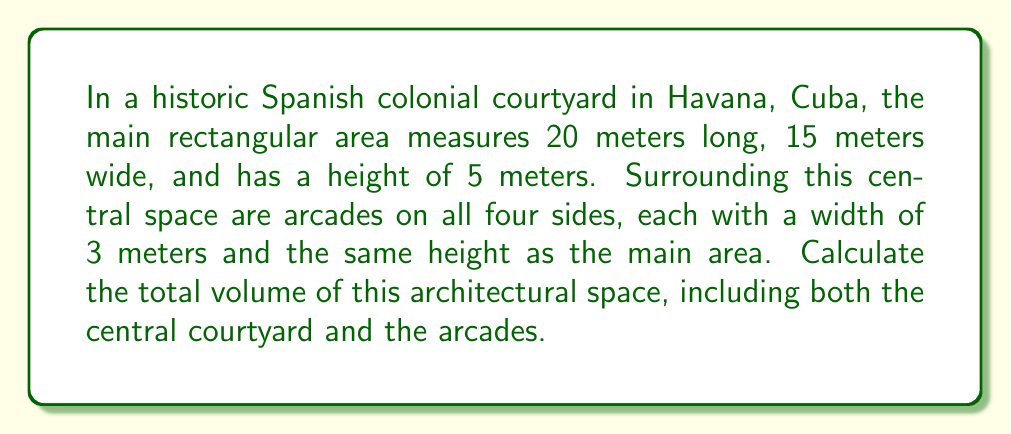Can you answer this question? Let's approach this step-by-step:

1) First, calculate the volume of the central rectangular courtyard:
   $$V_{central} = l \times w \times h = 20 \text{ m} \times 15 \text{ m} \times 5 \text{ m} = 1500 \text{ m}^3$$

2) Now, we need to calculate the volume of the arcades. There are four arcades:
   - Two along the length (20 m)
   - Two along the width (15 m)

3) Volume of arcades along the length:
   $$V_{length} = 2 \times (l \times w_{arcade} \times h) = 2 \times (20 \text{ m} \times 3 \text{ m} \times 5 \text{ m}) = 600 \text{ m}^3$$

4) Volume of arcades along the width:
   $$V_{width} = 2 \times ((w - 2w_{arcade}) \times w_{arcade} \times h)$$
   $$= 2 \times ((15 \text{ m} - 2 \times 3 \text{ m}) \times 3 \text{ m} \times 5 \text{ m}) = 270 \text{ m}^3$$

   Note: We subtract $2w_{arcade}$ from the width to avoid counting the corner spaces twice.

5) Total volume of arcades:
   $$V_{arcades} = V_{length} + V_{width} = 600 \text{ m}^3 + 270 \text{ m}^3 = 870 \text{ m}^3$$

6) Total volume of the entire space:
   $$V_{total} = V_{central} + V_{arcades} = 1500 \text{ m}^3 + 870 \text{ m}^3 = 2370 \text{ m}^3$$
Answer: $2370 \text{ m}^3$ 